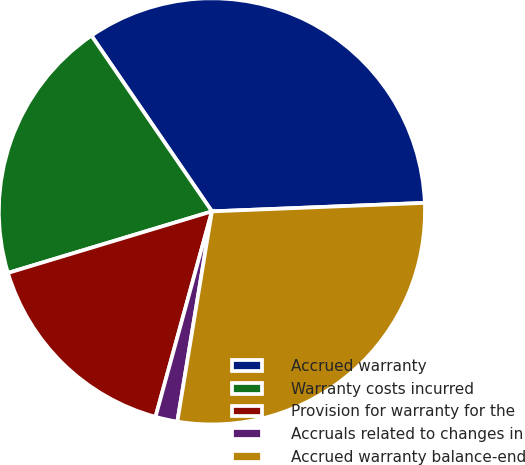<chart> <loc_0><loc_0><loc_500><loc_500><pie_chart><fcel>Accrued warranty<fcel>Warranty costs incurred<fcel>Provision for warranty for the<fcel>Accruals related to changes in<fcel>Accrued warranty balance-end<nl><fcel>33.93%<fcel>20.1%<fcel>16.07%<fcel>1.67%<fcel>28.23%<nl></chart> 